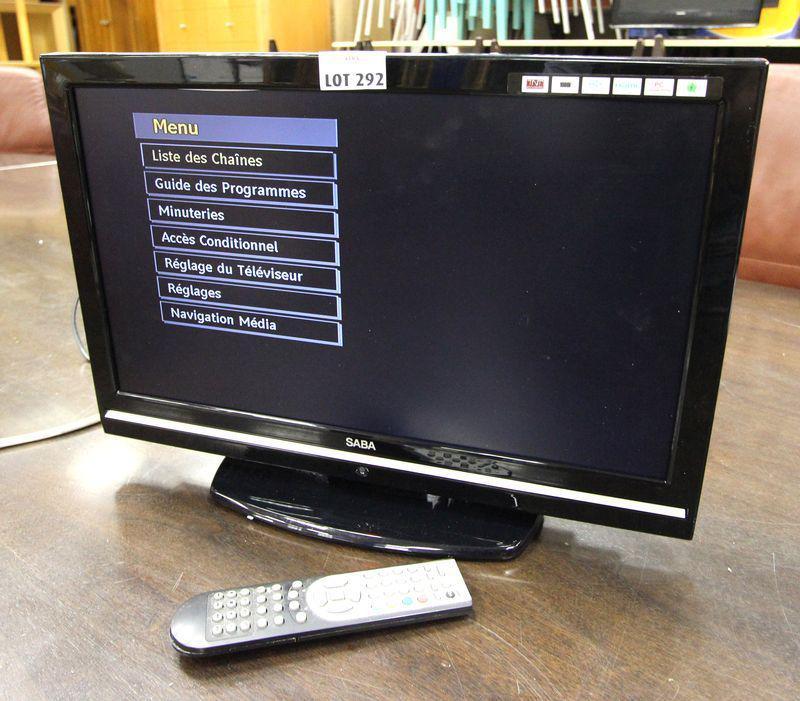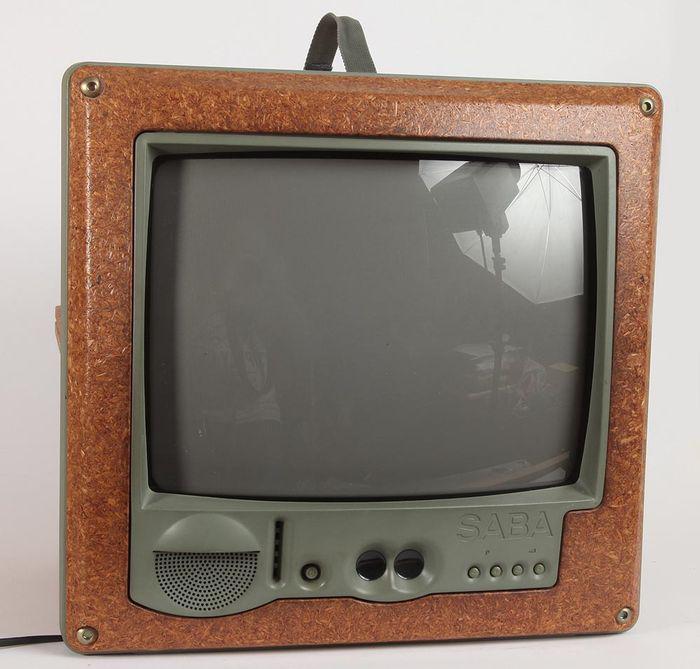The first image is the image on the left, the second image is the image on the right. For the images shown, is this caption "The left image has a remote next to a monitor on a wooden surface" true? Answer yes or no. Yes. The first image is the image on the left, the second image is the image on the right. For the images displayed, is the sentence "the left pic is of a flat screen monitor" factually correct? Answer yes or no. Yes. 